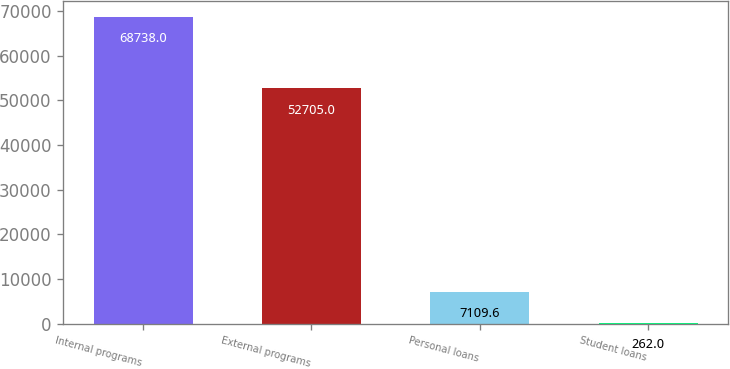<chart> <loc_0><loc_0><loc_500><loc_500><bar_chart><fcel>Internal programs<fcel>External programs<fcel>Personal loans<fcel>Student loans<nl><fcel>68738<fcel>52705<fcel>7109.6<fcel>262<nl></chart> 